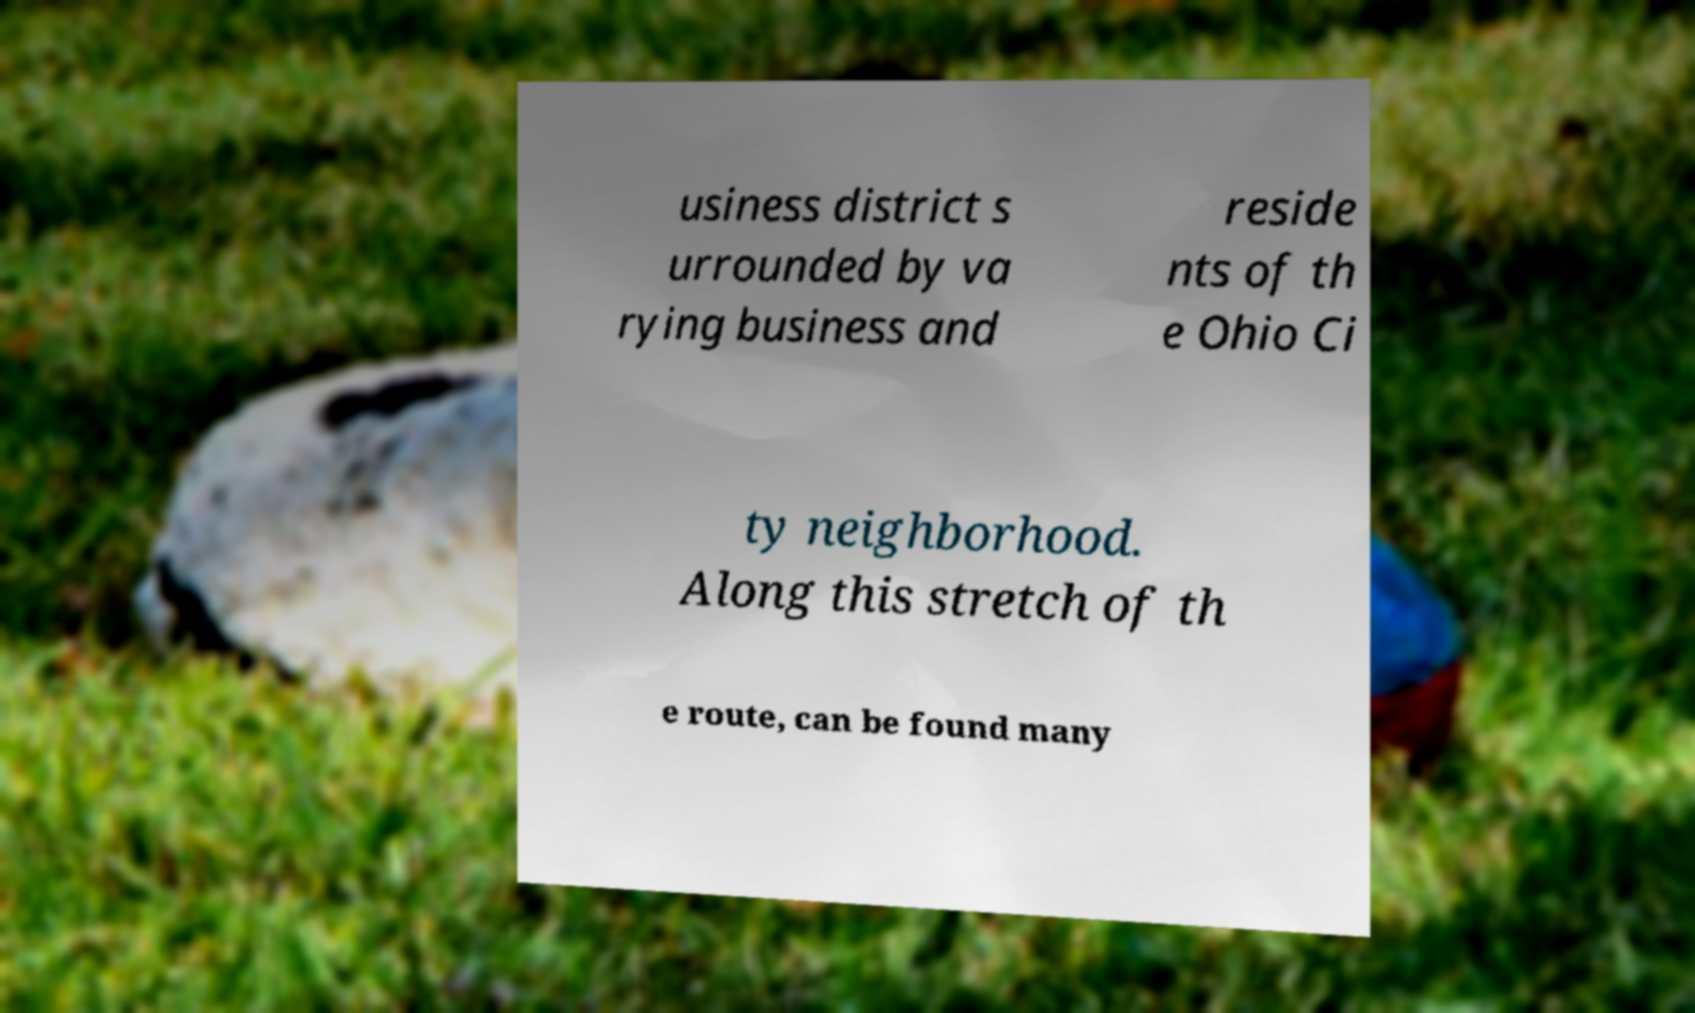Can you read and provide the text displayed in the image?This photo seems to have some interesting text. Can you extract and type it out for me? usiness district s urrounded by va rying business and reside nts of th e Ohio Ci ty neighborhood. Along this stretch of th e route, can be found many 